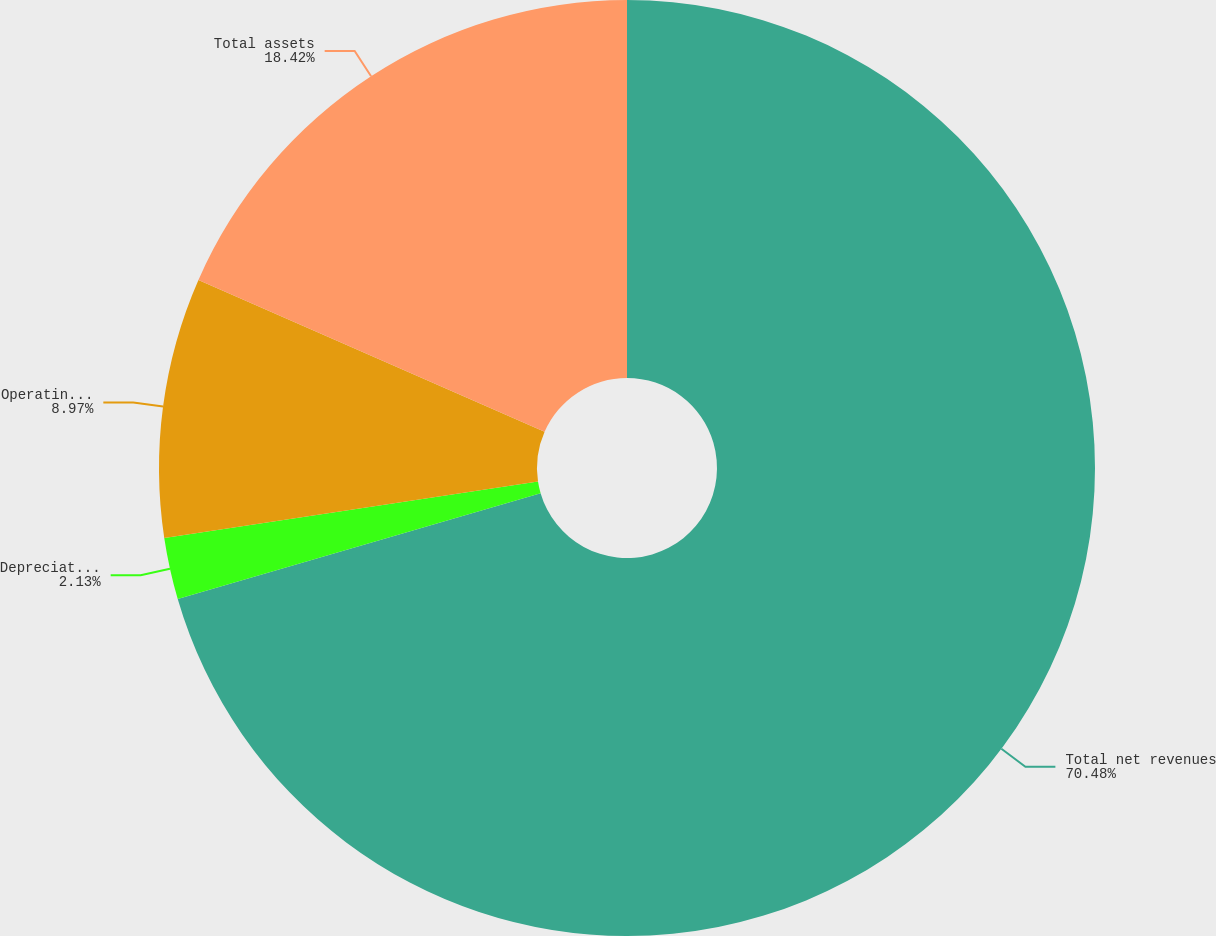<chart> <loc_0><loc_0><loc_500><loc_500><pie_chart><fcel>Total net revenues<fcel>Depreciation and amortization<fcel>Operating income/(loss)<fcel>Total assets<nl><fcel>70.49%<fcel>2.13%<fcel>8.97%<fcel>18.42%<nl></chart> 